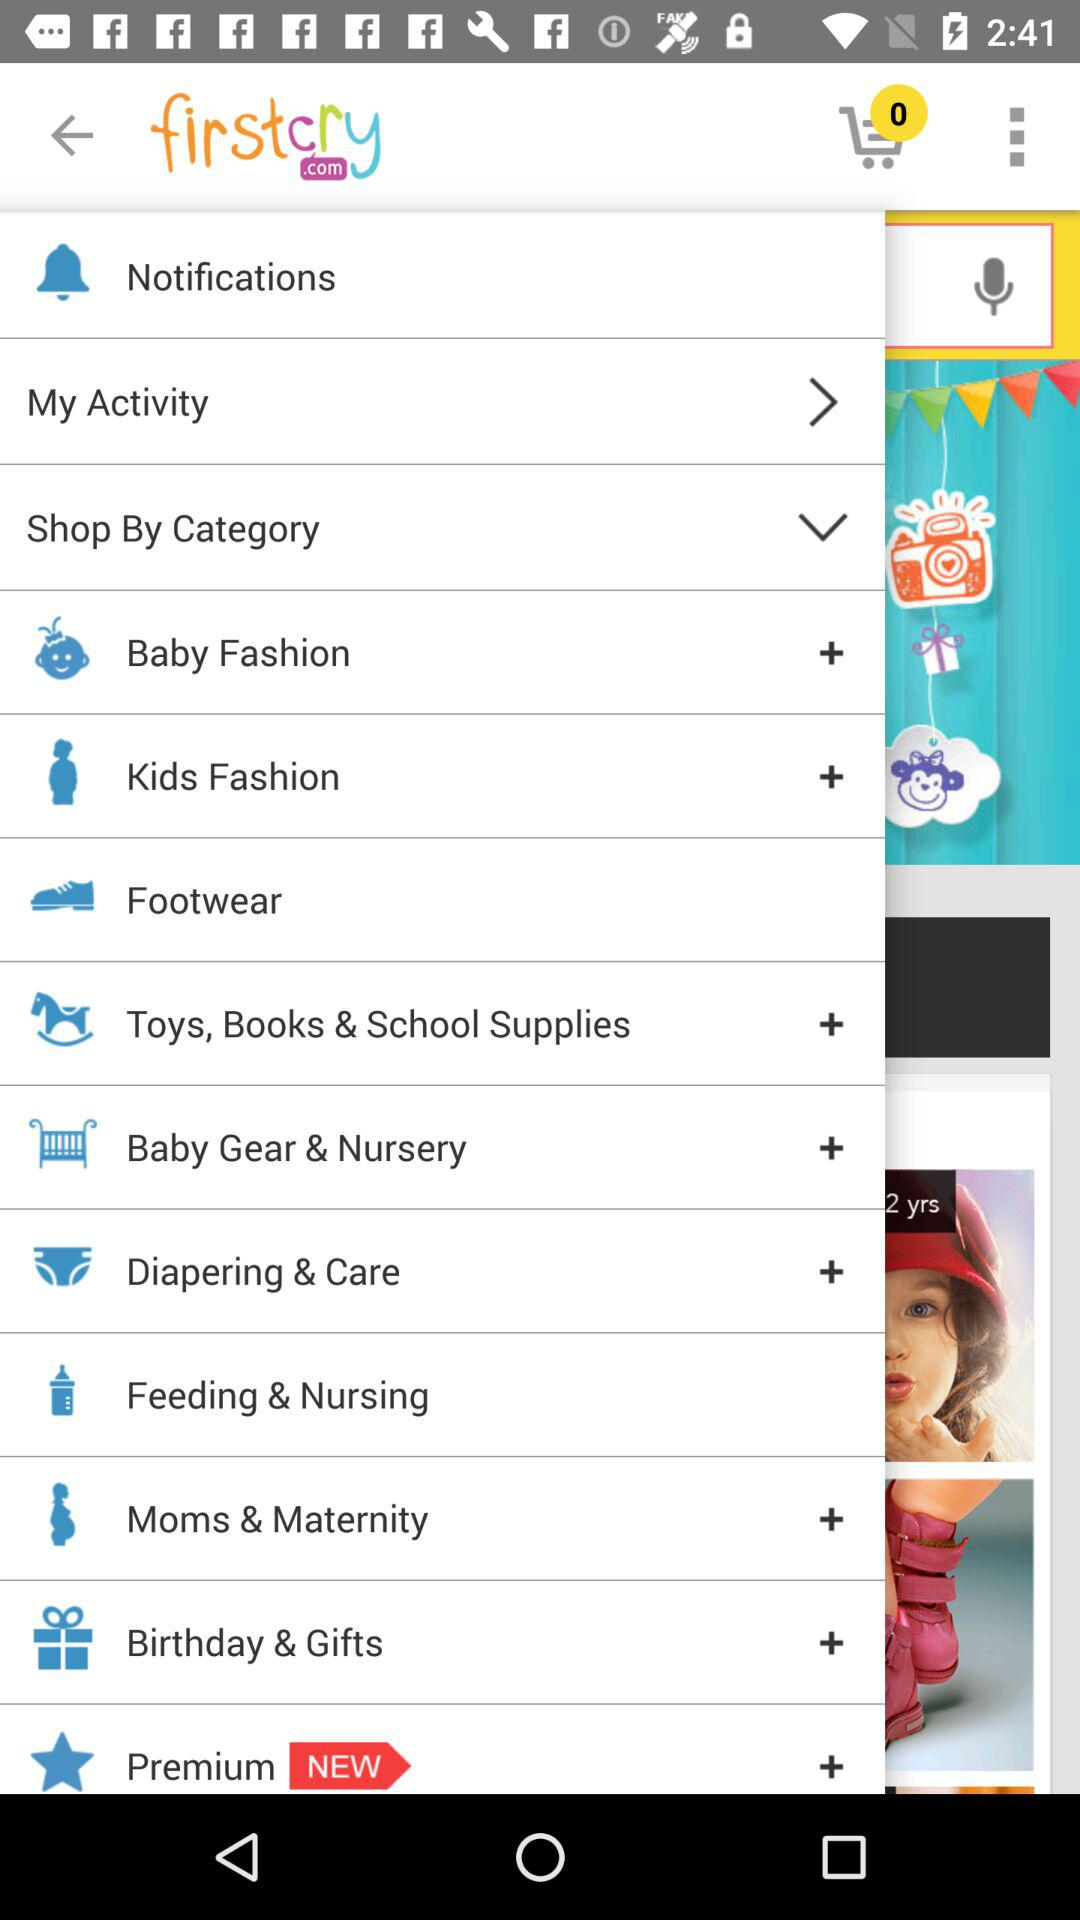What is the application name? The application name is "firstcry". 